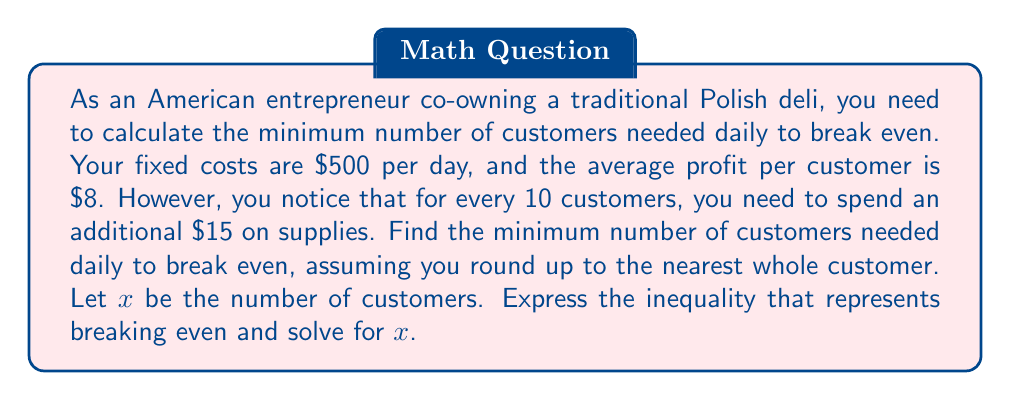Provide a solution to this math problem. Let's approach this step-by-step:

1) First, let's set up our inequality:

   Revenue - Costs $\geq$ 0

2) Now, let's break down each component:

   Revenue = $8x$ (profit per customer times number of customers)
   
   Costs = $500 + 15\lfloor\frac{x}{10}\rfloor$ (fixed costs plus additional supplies cost)

   Where $\lfloor\frac{x}{10}\rfloor$ represents the floor function, giving us the number of complete sets of 10 customers.

3) Our inequality becomes:

   $8x - (500 + 15\lfloor\frac{x}{10}\rfloor) \geq 0$

4) Simplifying:

   $8x - 500 - 15\lfloor\frac{x}{10}\rfloor \geq 0$

5) To solve this, we need to consider the floor function. Let's solve it for different ranges of $x$:

   For $0 \leq x < 10$: $8x - 500 \geq 0$
                        $x \geq 62.5$

   For $10 \leq x < 20$: $8x - 500 - 15 \geq 0$
                         $x \geq 64.375$

   For $20 \leq x < 30$: $8x - 500 - 30 \geq 0$
                         $x \geq 66.25$

6) We can see that the solution will be in the range $60 < x < 70$. In this range, the floor function will equal 6.

7) So our final inequality is:

   $8x - 500 - 15(6) \geq 0$
   $8x - 590 \geq 0$
   $8x \geq 590$
   $x \geq 73.75$

8) Since we need to round up to the nearest whole customer, our final answer is 74.
Answer: The minimum number of customers needed daily to break even is 74. 